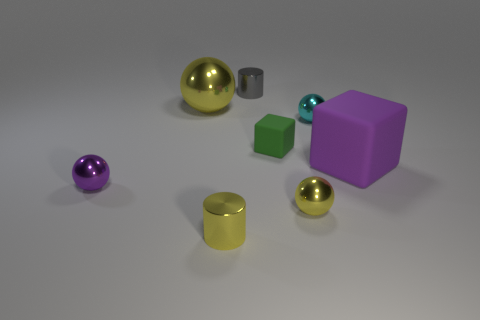Is the number of objects greater than the number of big blocks?
Offer a very short reply. Yes. The cylinder that is the same color as the big shiny thing is what size?
Your response must be concise. Small. There is a purple object on the right side of the purple thing to the left of the big metal sphere; what is its shape?
Your answer should be compact. Cube. There is a yellow ball that is in front of the block that is on the right side of the tiny rubber block; are there any yellow objects that are in front of it?
Ensure brevity in your answer.  Yes. There is a metallic thing that is the same size as the purple cube; what color is it?
Provide a short and direct response. Yellow. What shape is the small metal object that is behind the purple ball and on the left side of the cyan object?
Provide a succinct answer. Cylinder. How big is the shiny cylinder right of the tiny cylinder left of the gray cylinder?
Your answer should be compact. Small. What number of large blocks are the same color as the big sphere?
Provide a succinct answer. 0. How many other objects are the same size as the cyan object?
Offer a very short reply. 5. What size is the ball that is both in front of the tiny green thing and on the right side of the green object?
Your answer should be very brief. Small. 